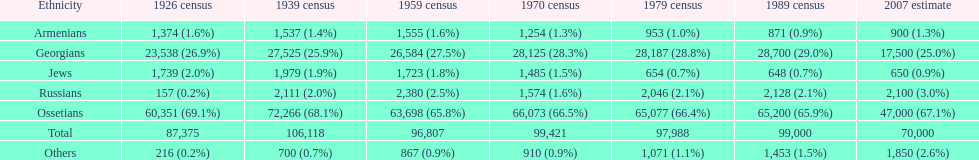Which population had the most people in 1926? Ossetians. 